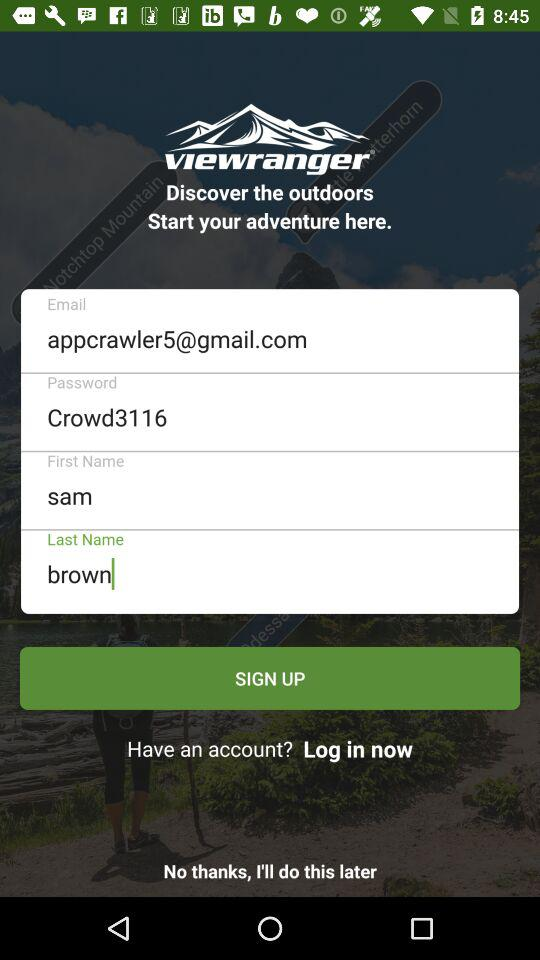What is the password? The password is Crowd3116. 